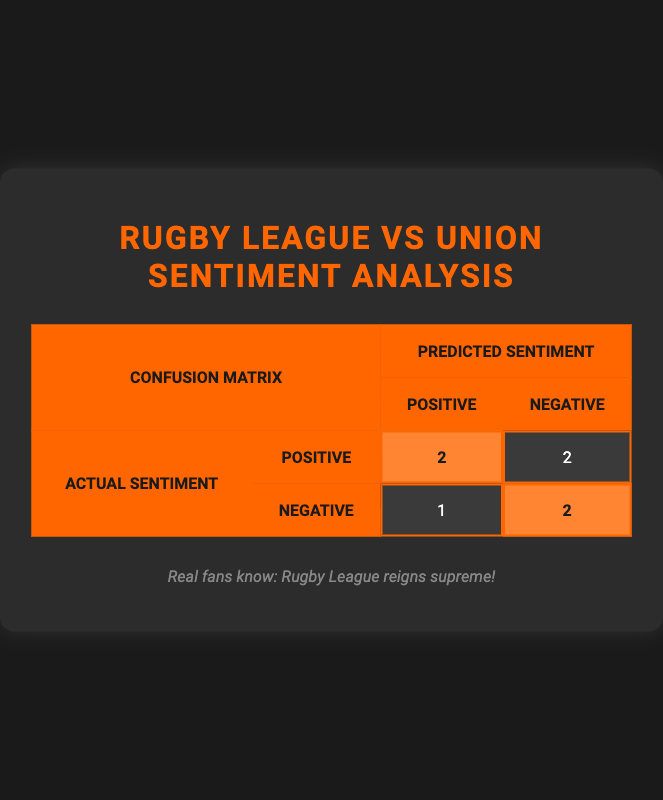What is the total number of positive sentiment predictions? The matrix shows that there are 2 positive predictions when the actual sentiment is positive and 1 positive prediction when the actual sentiment is negative. Summing these gives 2 + 1 = 3.
Answer: 3 How many negative sentiment predictions are there when the actual sentiment is negative? The table indicates that there are 2 cases where the actual sentiment is negative and the predicted sentiment is also negative. This is directly visible in the table.
Answer: 2 Is it true that there are more true positive predictions than false negatives? Looking at the counts, there are 2 true positive predictions (actual and predicted sentiment both positive) and 1 false negative predicted (actual positive but predicted negative), thus the statement is true.
Answer: Yes What is the difference between the number of true positives and false positives? The number of true positive predictions is 2, while the false positives (actual negative but predicted positive) total 1. Subtracting these gives 2 - 1 = 1.
Answer: 1 Which sentiment prediction category has the highest count? In the confusion matrix, the positive sentiment predictions when the actual sentiment is positive have a count of 2, and the negative sentiment when the actual sentiment is negative also has a count of 2. However, they are tied.
Answer: They are tied If a user predicted the sentiment was positive, what are the chances it was actually negative? Looking at the table, the actual count for positive predictions is 3 (2 true positives, 1 false positive) while the total predictions were 5 (2 true positives, 2 false negatives, 1 false positive). Thus, the probability of being actually negative when predicted positive is 1 out of 3 instances: 1/3 or approximately 33.3%.
Answer: 33.3% How many predictions are there in total? The total number of predictions can be derived from the matrix. There are 6 predictions in total: 2 positives that are positive, 2 negatives that are negative, 1 false positive, and 1 false negative. Summing them gives 2 + 2 + 1 + 1 = 6.
Answer: 6 What is the proportion of truly positive sentiments to the total negative predictions? There are 2 truly positive sentiments from a total of 3 negative predictions (2 negatives that were predicted negative and 1 falsely predicted positive). The proportion is 2 out of 3, or 2/3.
Answer: 2/3 